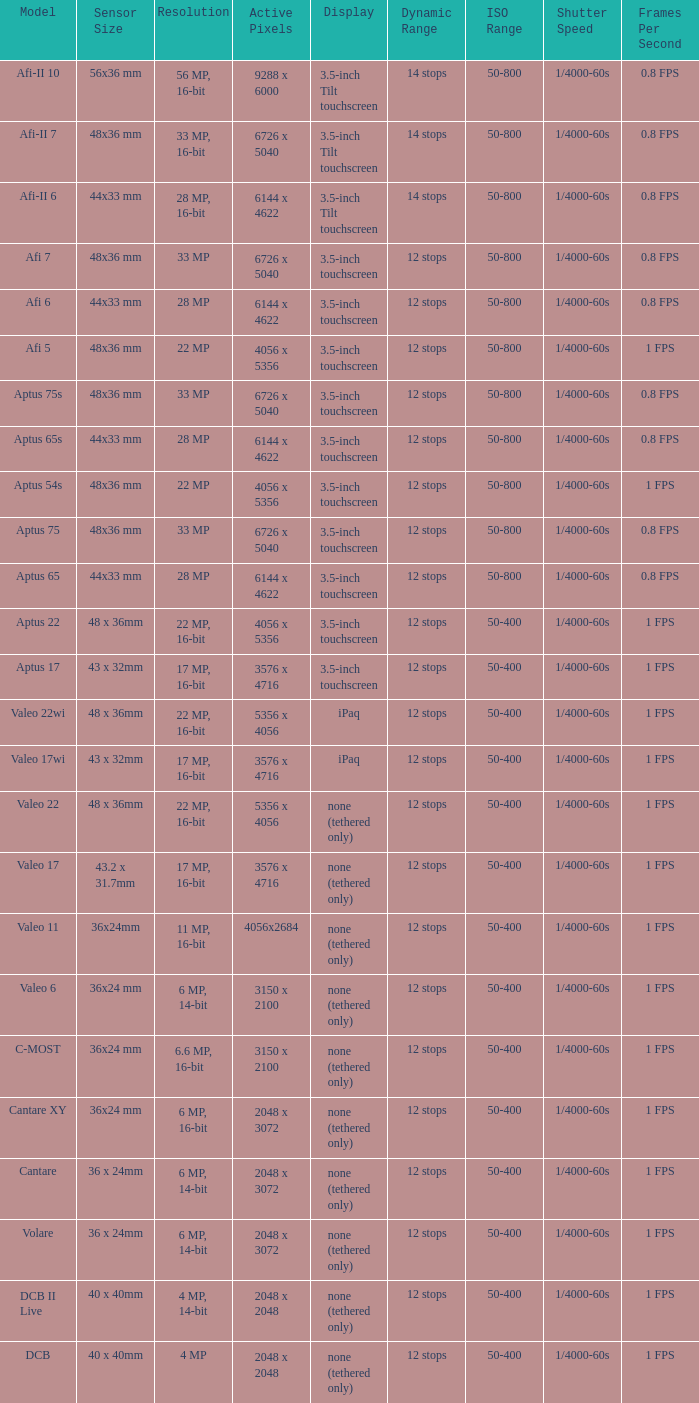What are the active pixels of the c-most model camera? 3150 x 2100. 